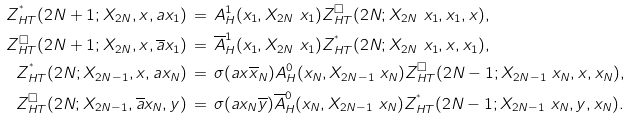<formula> <loc_0><loc_0><loc_500><loc_500>\, Z _ { H T } ^ { ^ { * } } ( 2 N + 1 ; X _ { 2 N } , x , a x _ { 1 } ) & \, = \, A _ { H } ^ { 1 } ( x _ { 1 } , X _ { 2 N } \ x _ { 1 } ) Z _ { H T } ^ { \square } ( 2 N ; X _ { 2 N } \ x _ { 1 } , x _ { 1 } , x ) , \\ \, Z _ { H T } ^ { \square } ( 2 N + 1 ; X _ { 2 N } , x , { \overline { a } x _ { 1 } } ) & \, = \, \overline { A } _ { H } ^ { 1 } ( x _ { 1 } , X _ { 2 N } \ x _ { 1 } ) Z _ { H T } ^ { ^ { * } } ( 2 N ; X _ { 2 N } \ x _ { 1 } , x , x _ { 1 } ) , \\ \, Z _ { H T } ^ { ^ { * } } ( 2 N ; X _ { 2 N - 1 } , x , { a x _ { N } } ) & \, = \, \sigma ( a x \overline { x } _ { N } ) A _ { H } ^ { 0 } ( x _ { N } , X _ { 2 N - 1 } \ x _ { N } ) Z _ { H T } ^ { \square } ( 2 N - 1 ; X _ { 2 N - 1 } \ x _ { N } , x , x _ { N } ) , \\ \, Z _ { H T } ^ { \square } ( 2 N ; X _ { 2 N - 1 } , { \overline { a } x _ { N } } , y ) & \, = \, \sigma ( a x _ { N } \overline { y } ) \overline { A } _ { H } ^ { 0 } ( x _ { N } , X _ { 2 N - 1 } \ x _ { N } ) Z _ { H T } ^ { ^ { * } } ( 2 N - 1 ; X _ { 2 N - 1 } \ x _ { N } , y , x _ { N } ) .</formula> 